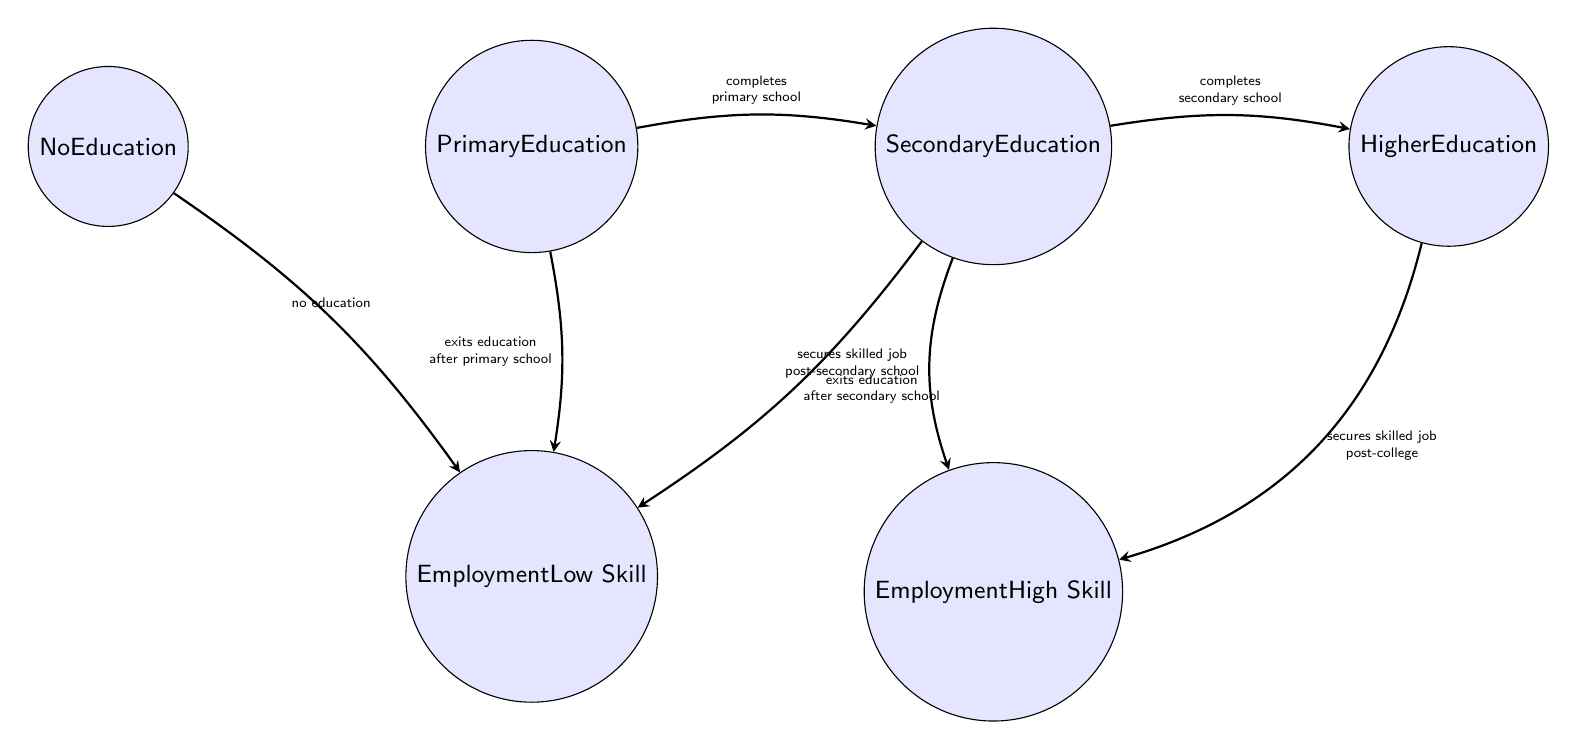What's the total number of states in the diagram? The diagram includes six states: No Education, Primary Education, Secondary Education, Higher Education, Employment Low Skill, and Employment High Skill. Counting each of these gives a total of six states.
Answer: 6 What transition occurs from Primary Education to Secondary Education? The diagram indicates that an individual moves from Primary Education to Secondary Education when they complete primary school. This is explicitly labeled on the arrow connecting these two states.
Answer: completes primary school Which state leads to Employment High Skill? The state that leads to Employment High Skill is Higher Education, as indicated by the transition shown in the diagram where an individual can secure a skilled job post-college.
Answer: Higher Education What happens if an individual exits education after Secondary School? Exiting education after Secondary School leads to Employment Low Skill as per the diagram. There is a specific transition showing this outcome for individuals who do not continue their education beyond secondary school.
Answer: Employment Low Skill How many transitions lead to Employment Low Skill? There are three transitions leading to Employment Low Skill: one from No Education and two from Primary and Secondary Education after exiting education. Therefore, summing these gives three transitions in total.
Answer: 3 What condition results in an individual securing a high-skilled job post-secondary school? According to the diagram, securing a high-skilled job post-secondary school occurs when an individual secures a skilled job after completing their Secondary Education. This condition specifically describes the transition to Employment High Skill from the Secondary Education state.
Answer: secures skilled job post-secondary school What is the primary educational step before an individual can attend Higher Education? The primary educational step before attending Higher Education is completing Secondary Education, as indicated in the diagram where the transition from Secondary Education to Higher Education takes place after completing secondary school.
Answer: Secondary Education Can an individual with no education obtain Employment High Skill directly? No, according to the diagram, an individual with no education cannot obtain Employment High Skill directly because they must first progress through the necessary educational states to reach that level of employment. The only path from No Education is to Employment Low Skill.
Answer: No 